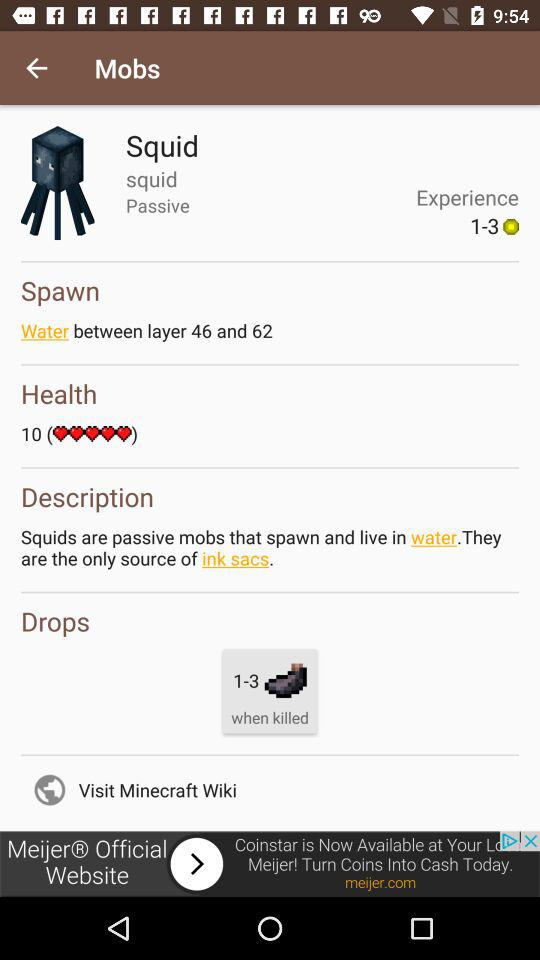What is the status of the squid?
When the provided information is insufficient, respond with <no answer>. <no answer> 